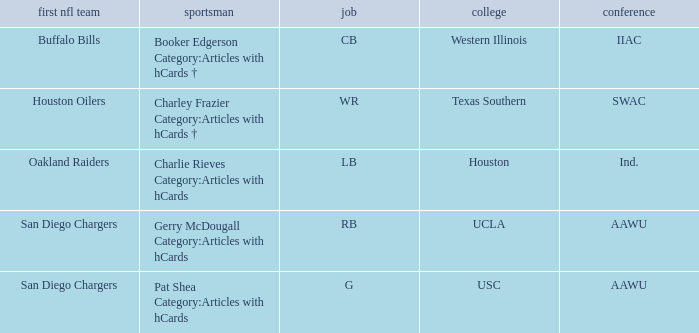What player's original team are the Buffalo Bills? Booker Edgerson Category:Articles with hCards †. 